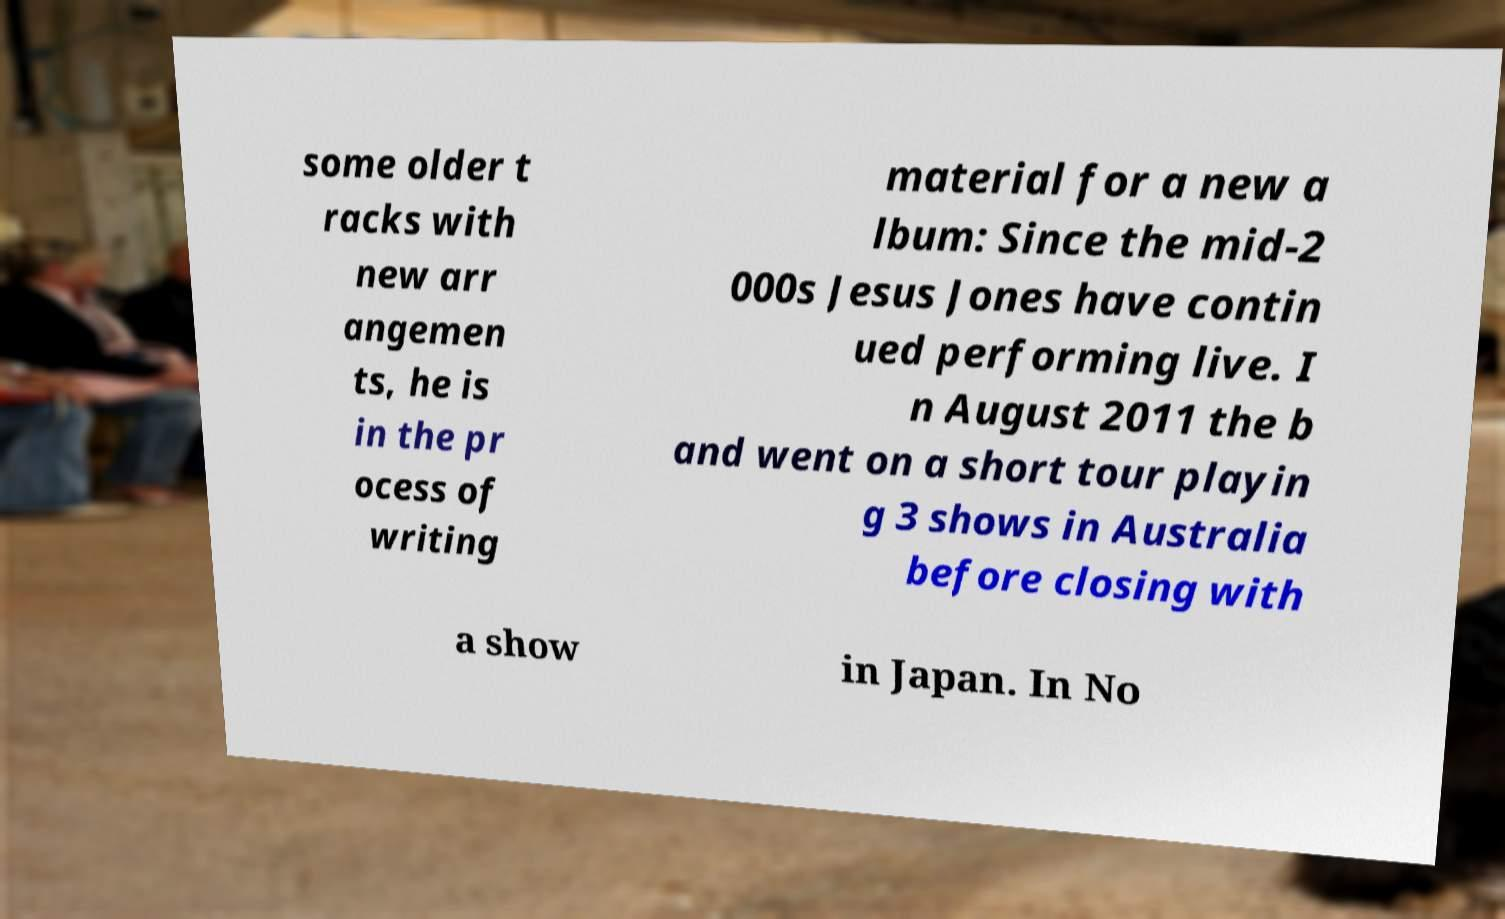For documentation purposes, I need the text within this image transcribed. Could you provide that? some older t racks with new arr angemen ts, he is in the pr ocess of writing material for a new a lbum: Since the mid-2 000s Jesus Jones have contin ued performing live. I n August 2011 the b and went on a short tour playin g 3 shows in Australia before closing with a show in Japan. In No 